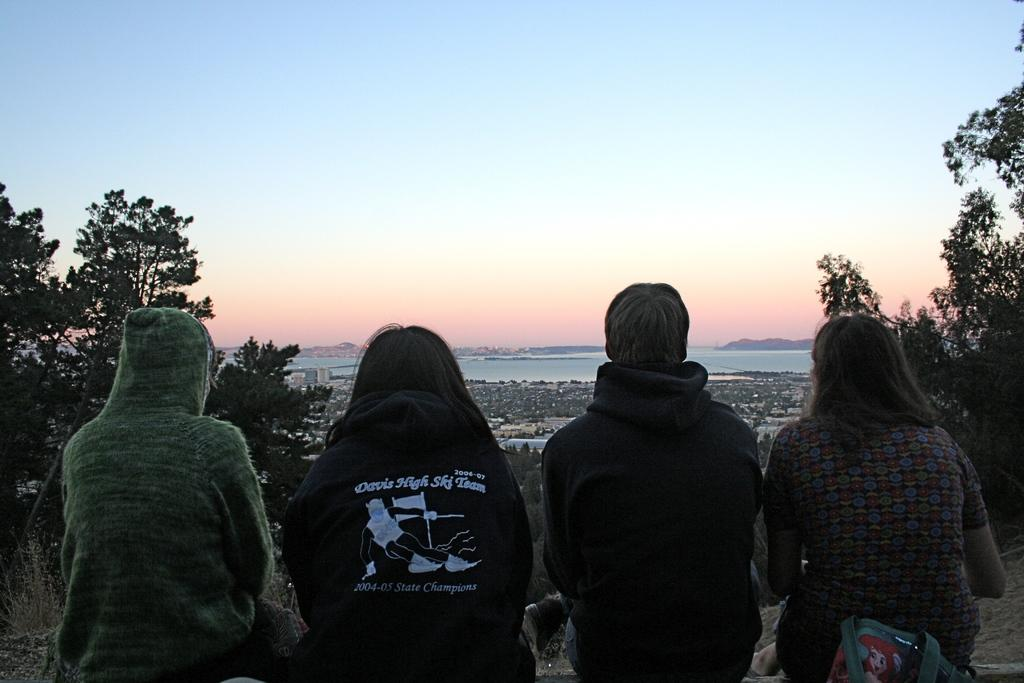What type of view is shown in the image? The image is an outside view. How many people are sitting in the foreground? There are four people sitting in the foreground. What can be seen in the background of the image? There are many trees and buildings in the background. What is visible at the top of the image? The sky is visible at the top of the image. What type of attack is being carried out by the aunt in the image? There is no aunt or attack present in the image. How many quarters are visible in the image? There are no quarters visible in the image. 